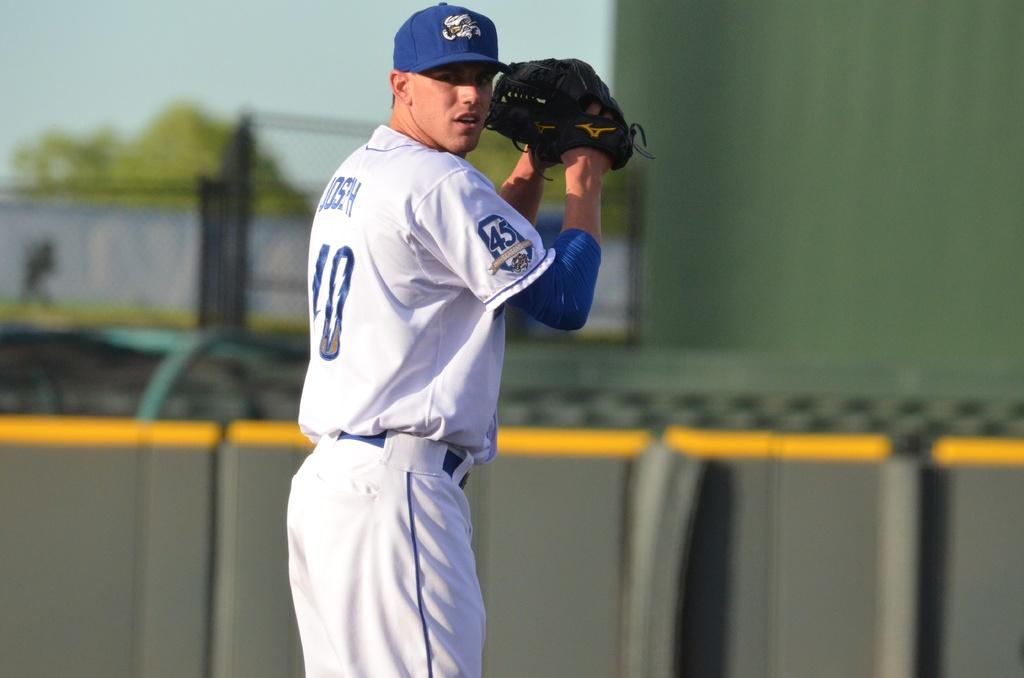<image>
Render a clear and concise summary of the photo. The players name is Joseph and he is wearing number 10 